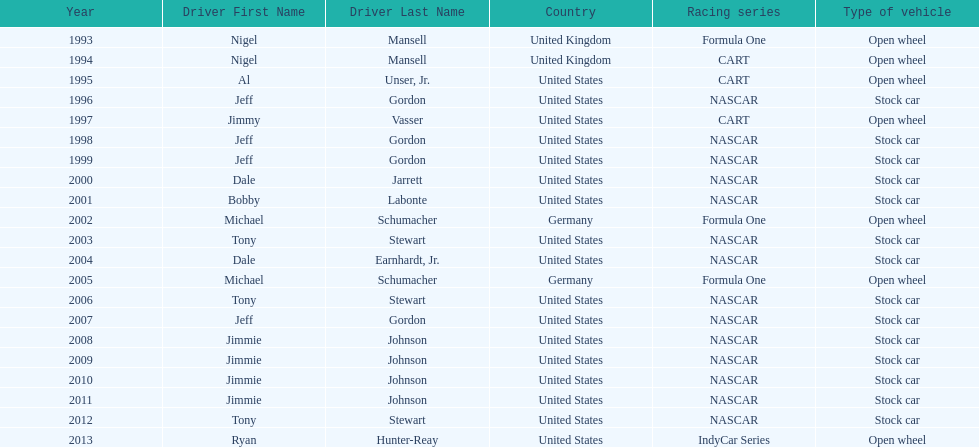How many times did jeff gordon win the award? 4. 